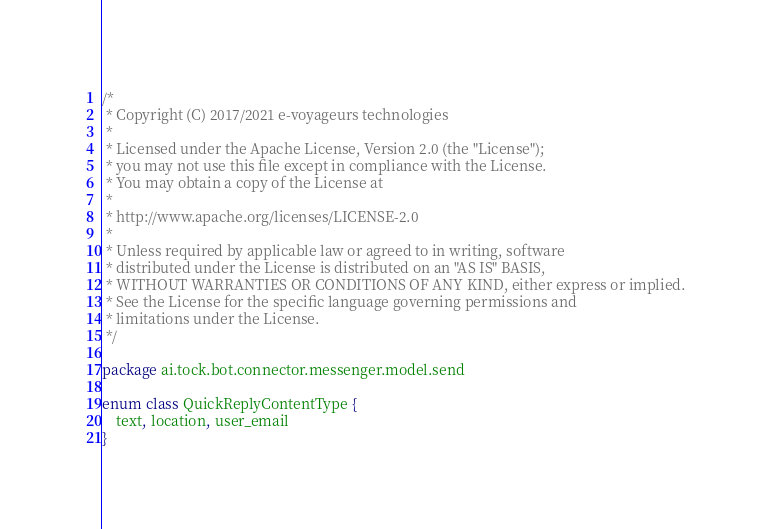<code> <loc_0><loc_0><loc_500><loc_500><_Kotlin_>/*
 * Copyright (C) 2017/2021 e-voyageurs technologies
 *
 * Licensed under the Apache License, Version 2.0 (the "License");
 * you may not use this file except in compliance with the License.
 * You may obtain a copy of the License at
 *
 * http://www.apache.org/licenses/LICENSE-2.0
 *
 * Unless required by applicable law or agreed to in writing, software
 * distributed under the License is distributed on an "AS IS" BASIS,
 * WITHOUT WARRANTIES OR CONDITIONS OF ANY KIND, either express or implied.
 * See the License for the specific language governing permissions and
 * limitations under the License.
 */

package ai.tock.bot.connector.messenger.model.send

enum class QuickReplyContentType {
    text, location, user_email
}
</code> 